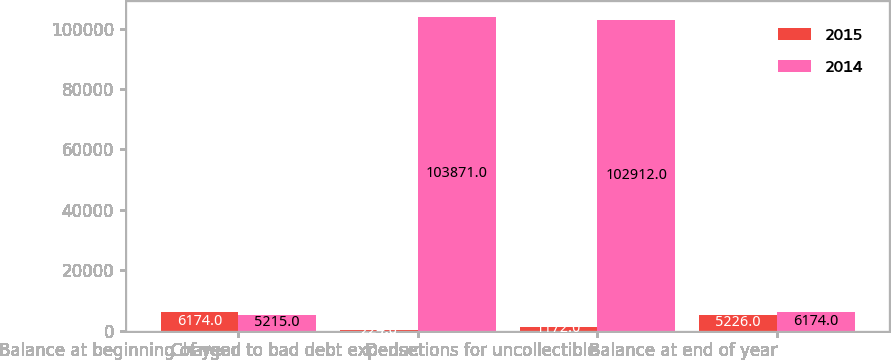Convert chart. <chart><loc_0><loc_0><loc_500><loc_500><stacked_bar_chart><ecel><fcel>Balance at beginning of year<fcel>Charged to bad debt expense<fcel>Deductions for uncollectible<fcel>Balance at end of year<nl><fcel>2015<fcel>6174<fcel>224<fcel>1172<fcel>5226<nl><fcel>2014<fcel>5215<fcel>103871<fcel>102912<fcel>6174<nl></chart> 